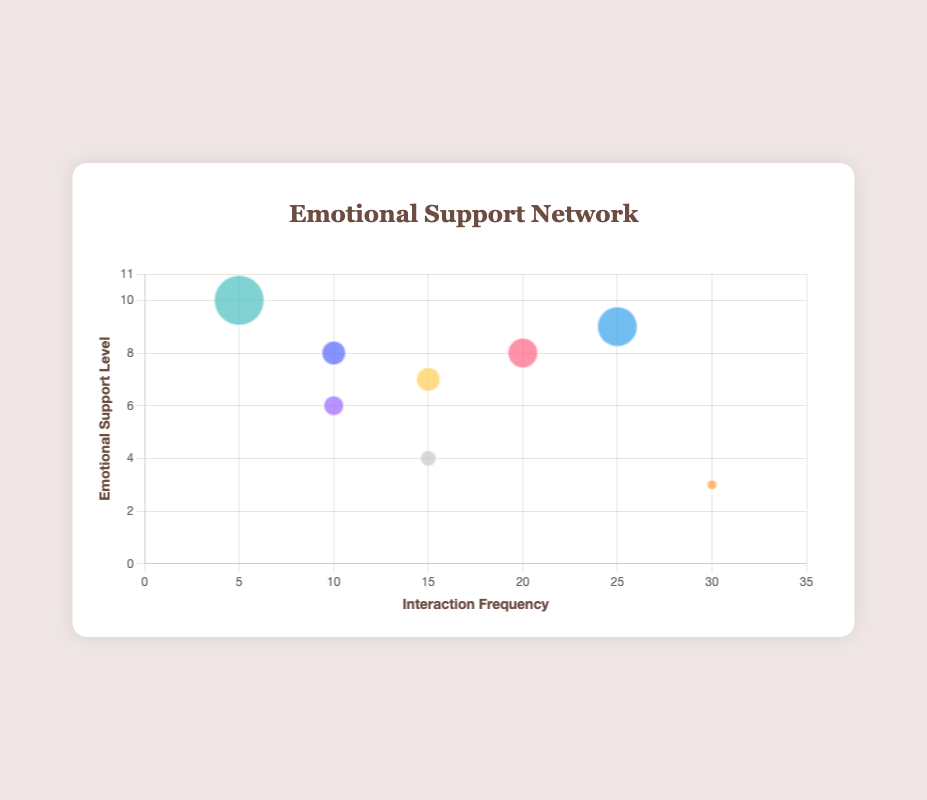What is the title of the figure? The title is written at the top of the figure and reads "Emotional Support Network."
Answer: Emotional Support Network What do the X and Y axes represent in the figure? The labels at the bottom and left side of the chart indicate that the X axis represents "Interaction Frequency" and the Y axis represents "Emotional Support Level."
Answer: Interaction Frequency and Emotional Support Level Which social interaction entity has the highest emotional support level? By observing the Y axis, the highest data point is at the top (emotional support level = 10), which corresponds to the "Therapist."
Answer: Therapist How many social interaction entities are represented in the figure? There are eight bubbles in the chart, each representing a social interaction entity.
Answer: 8 What is the emotional support level for "Casual Acquaintances"? The bubble corresponding to "Casual Acquaintances" is shown at an emotional support level (Y axis) of 3.
Answer: 3 Which entity has the highest interaction frequency? The bubble at the farthest right end of the X axis, indicating the highest interaction frequency, corresponds to "Casual Acquaintances."
Answer: Casual Acquaintances Which entities have an emotional support level of 8? By looking at Y = 8, the corresponding bubbles are "Family" and "Self-Reflection."
Answer: Family and Self-Reflection How do the interaction frequency and emotional support level of "Close Friends" compare to those of "Family"? "Close Friends" has a higher interaction frequency (25 vs. 20) and a slightly higher emotional support level (9 vs. 8) compared to "Family."
Answer: Higher frequency and slightly higher support Which social interaction entity has the smallest marker size, and what is its interaction frequency? The smallest marker indicates "Casual Acquaintances," and its interaction frequency (X axis) is 30.
Answer: Casual Acquaintances, 30 What is the average emotional support level among the entities "Family," "Close Friends," and "Art Community"? The emotional support levels are 8, 9, and 7. The average is calculated as (8+9+7)/3 = 24/3 = 8.
Answer: 8 